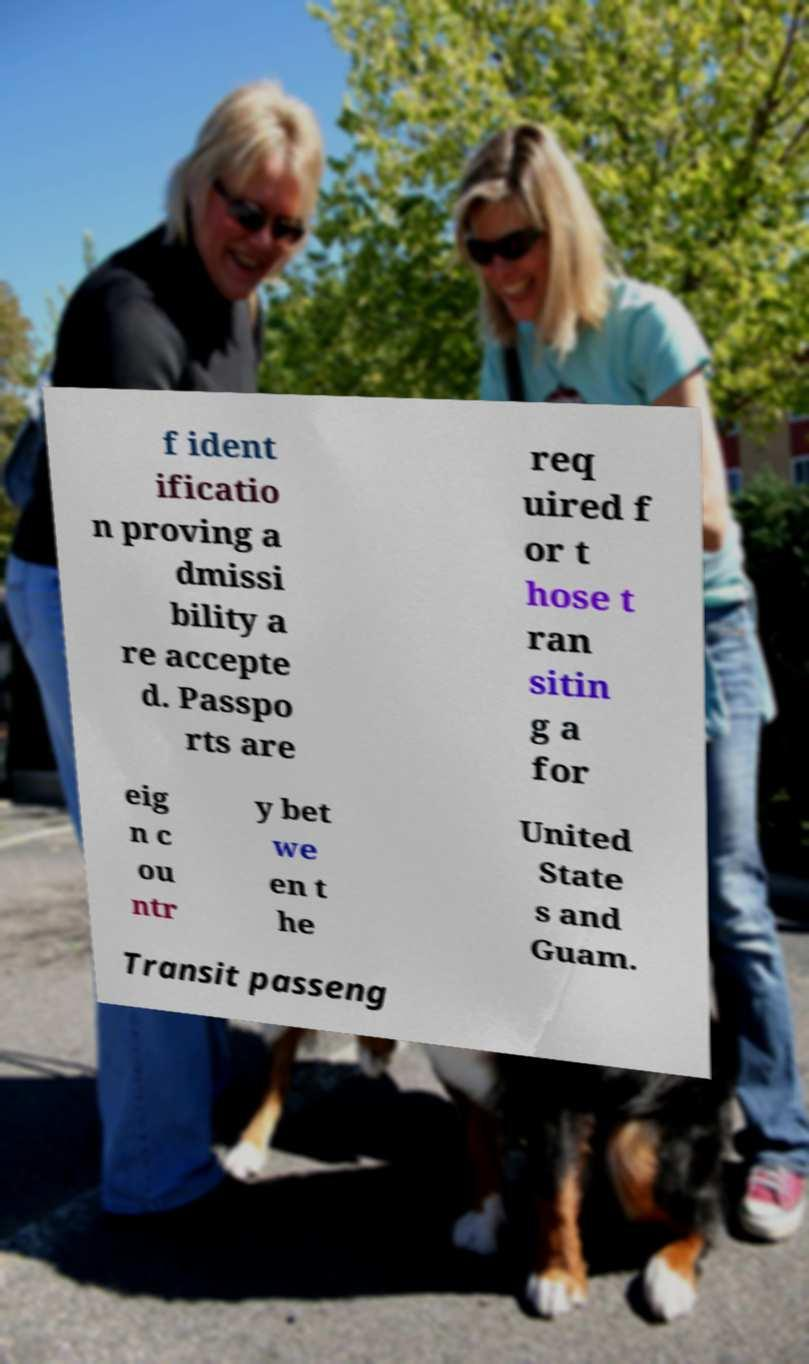What messages or text are displayed in this image? I need them in a readable, typed format. f ident ificatio n proving a dmissi bility a re accepte d. Passpo rts are req uired f or t hose t ran sitin g a for eig n c ou ntr y bet we en t he United State s and Guam. Transit passeng 